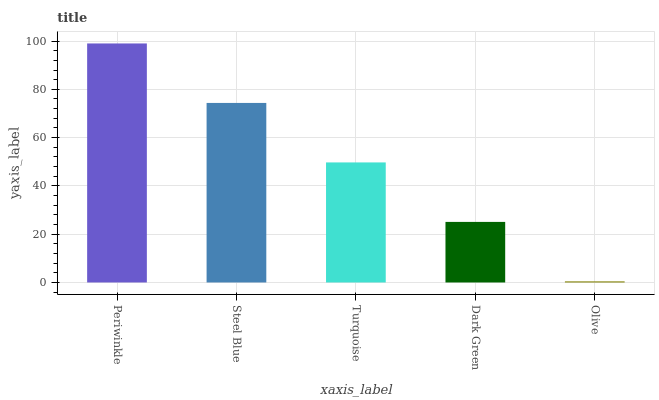Is Olive the minimum?
Answer yes or no. Yes. Is Periwinkle the maximum?
Answer yes or no. Yes. Is Steel Blue the minimum?
Answer yes or no. No. Is Steel Blue the maximum?
Answer yes or no. No. Is Periwinkle greater than Steel Blue?
Answer yes or no. Yes. Is Steel Blue less than Periwinkle?
Answer yes or no. Yes. Is Steel Blue greater than Periwinkle?
Answer yes or no. No. Is Periwinkle less than Steel Blue?
Answer yes or no. No. Is Turquoise the high median?
Answer yes or no. Yes. Is Turquoise the low median?
Answer yes or no. Yes. Is Periwinkle the high median?
Answer yes or no. No. Is Steel Blue the low median?
Answer yes or no. No. 